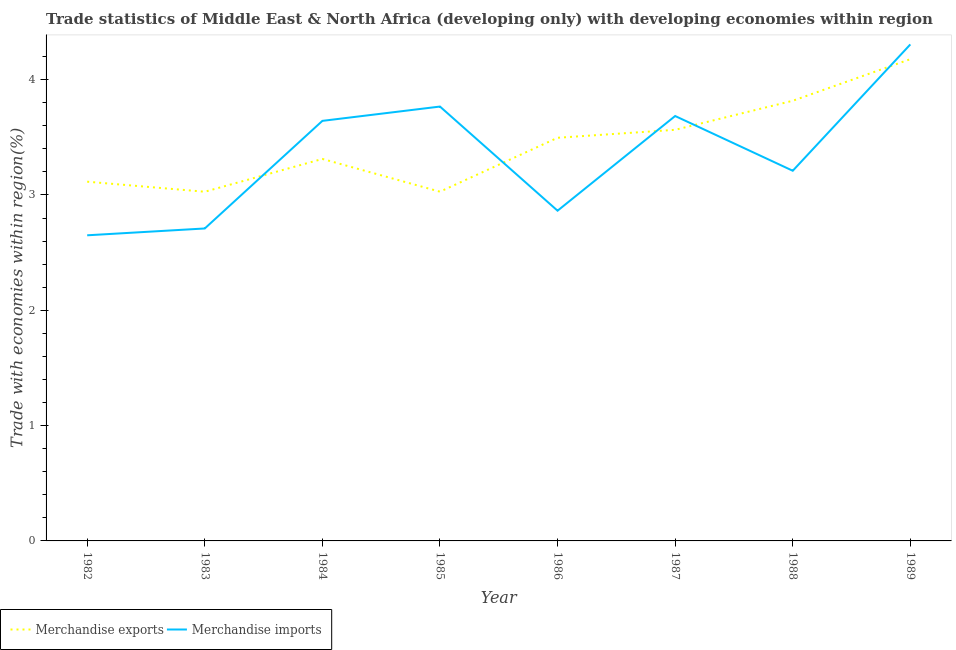How many different coloured lines are there?
Ensure brevity in your answer.  2. Does the line corresponding to merchandise exports intersect with the line corresponding to merchandise imports?
Provide a short and direct response. Yes. Is the number of lines equal to the number of legend labels?
Make the answer very short. Yes. What is the merchandise imports in 1987?
Your response must be concise. 3.68. Across all years, what is the maximum merchandise imports?
Ensure brevity in your answer.  4.31. Across all years, what is the minimum merchandise imports?
Provide a short and direct response. 2.65. In which year was the merchandise exports maximum?
Your response must be concise. 1989. What is the total merchandise imports in the graph?
Give a very brief answer. 26.83. What is the difference between the merchandise imports in 1982 and that in 1988?
Keep it short and to the point. -0.56. What is the difference between the merchandise exports in 1985 and the merchandise imports in 1984?
Ensure brevity in your answer.  -0.61. What is the average merchandise imports per year?
Your answer should be very brief. 3.35. In the year 1988, what is the difference between the merchandise exports and merchandise imports?
Make the answer very short. 0.61. What is the ratio of the merchandise imports in 1984 to that in 1987?
Keep it short and to the point. 0.99. What is the difference between the highest and the second highest merchandise imports?
Offer a terse response. 0.54. What is the difference between the highest and the lowest merchandise imports?
Your answer should be compact. 1.66. In how many years, is the merchandise imports greater than the average merchandise imports taken over all years?
Offer a very short reply. 4. Is the sum of the merchandise exports in 1983 and 1989 greater than the maximum merchandise imports across all years?
Provide a short and direct response. Yes. Is the merchandise exports strictly greater than the merchandise imports over the years?
Provide a succinct answer. No. How many lines are there?
Provide a short and direct response. 2. Are the values on the major ticks of Y-axis written in scientific E-notation?
Give a very brief answer. No. Does the graph contain any zero values?
Your response must be concise. No. Where does the legend appear in the graph?
Provide a succinct answer. Bottom left. How many legend labels are there?
Provide a short and direct response. 2. What is the title of the graph?
Ensure brevity in your answer.  Trade statistics of Middle East & North Africa (developing only) with developing economies within region. Does "Primary" appear as one of the legend labels in the graph?
Ensure brevity in your answer.  No. What is the label or title of the X-axis?
Your answer should be compact. Year. What is the label or title of the Y-axis?
Offer a terse response. Trade with economies within region(%). What is the Trade with economies within region(%) of Merchandise exports in 1982?
Give a very brief answer. 3.12. What is the Trade with economies within region(%) of Merchandise imports in 1982?
Your answer should be compact. 2.65. What is the Trade with economies within region(%) in Merchandise exports in 1983?
Your answer should be very brief. 3.03. What is the Trade with economies within region(%) of Merchandise imports in 1983?
Provide a short and direct response. 2.71. What is the Trade with economies within region(%) in Merchandise exports in 1984?
Ensure brevity in your answer.  3.31. What is the Trade with economies within region(%) in Merchandise imports in 1984?
Provide a short and direct response. 3.64. What is the Trade with economies within region(%) in Merchandise exports in 1985?
Provide a short and direct response. 3.03. What is the Trade with economies within region(%) in Merchandise imports in 1985?
Offer a terse response. 3.77. What is the Trade with economies within region(%) of Merchandise exports in 1986?
Offer a very short reply. 3.5. What is the Trade with economies within region(%) of Merchandise imports in 1986?
Offer a terse response. 2.86. What is the Trade with economies within region(%) in Merchandise exports in 1987?
Offer a very short reply. 3.57. What is the Trade with economies within region(%) of Merchandise imports in 1987?
Offer a very short reply. 3.68. What is the Trade with economies within region(%) in Merchandise exports in 1988?
Offer a terse response. 3.82. What is the Trade with economies within region(%) of Merchandise imports in 1988?
Your answer should be compact. 3.21. What is the Trade with economies within region(%) of Merchandise exports in 1989?
Offer a very short reply. 4.18. What is the Trade with economies within region(%) of Merchandise imports in 1989?
Provide a short and direct response. 4.31. Across all years, what is the maximum Trade with economies within region(%) of Merchandise exports?
Give a very brief answer. 4.18. Across all years, what is the maximum Trade with economies within region(%) in Merchandise imports?
Keep it short and to the point. 4.31. Across all years, what is the minimum Trade with economies within region(%) in Merchandise exports?
Provide a succinct answer. 3.03. Across all years, what is the minimum Trade with economies within region(%) of Merchandise imports?
Ensure brevity in your answer.  2.65. What is the total Trade with economies within region(%) in Merchandise exports in the graph?
Your answer should be very brief. 27.54. What is the total Trade with economies within region(%) of Merchandise imports in the graph?
Ensure brevity in your answer.  26.83. What is the difference between the Trade with economies within region(%) in Merchandise exports in 1982 and that in 1983?
Ensure brevity in your answer.  0.09. What is the difference between the Trade with economies within region(%) of Merchandise imports in 1982 and that in 1983?
Keep it short and to the point. -0.06. What is the difference between the Trade with economies within region(%) in Merchandise exports in 1982 and that in 1984?
Your answer should be compact. -0.2. What is the difference between the Trade with economies within region(%) in Merchandise imports in 1982 and that in 1984?
Your answer should be compact. -0.99. What is the difference between the Trade with economies within region(%) in Merchandise exports in 1982 and that in 1985?
Your response must be concise. 0.09. What is the difference between the Trade with economies within region(%) in Merchandise imports in 1982 and that in 1985?
Keep it short and to the point. -1.12. What is the difference between the Trade with economies within region(%) of Merchandise exports in 1982 and that in 1986?
Give a very brief answer. -0.38. What is the difference between the Trade with economies within region(%) in Merchandise imports in 1982 and that in 1986?
Make the answer very short. -0.21. What is the difference between the Trade with economies within region(%) in Merchandise exports in 1982 and that in 1987?
Your answer should be very brief. -0.45. What is the difference between the Trade with economies within region(%) in Merchandise imports in 1982 and that in 1987?
Keep it short and to the point. -1.03. What is the difference between the Trade with economies within region(%) in Merchandise exports in 1982 and that in 1988?
Keep it short and to the point. -0.7. What is the difference between the Trade with economies within region(%) of Merchandise imports in 1982 and that in 1988?
Give a very brief answer. -0.56. What is the difference between the Trade with economies within region(%) in Merchandise exports in 1982 and that in 1989?
Provide a succinct answer. -1.06. What is the difference between the Trade with economies within region(%) in Merchandise imports in 1982 and that in 1989?
Your answer should be compact. -1.66. What is the difference between the Trade with economies within region(%) in Merchandise exports in 1983 and that in 1984?
Offer a terse response. -0.28. What is the difference between the Trade with economies within region(%) of Merchandise imports in 1983 and that in 1984?
Give a very brief answer. -0.93. What is the difference between the Trade with economies within region(%) of Merchandise exports in 1983 and that in 1985?
Provide a short and direct response. -0. What is the difference between the Trade with economies within region(%) of Merchandise imports in 1983 and that in 1985?
Give a very brief answer. -1.06. What is the difference between the Trade with economies within region(%) of Merchandise exports in 1983 and that in 1986?
Provide a succinct answer. -0.47. What is the difference between the Trade with economies within region(%) in Merchandise imports in 1983 and that in 1986?
Provide a short and direct response. -0.15. What is the difference between the Trade with economies within region(%) of Merchandise exports in 1983 and that in 1987?
Provide a short and direct response. -0.54. What is the difference between the Trade with economies within region(%) of Merchandise imports in 1983 and that in 1987?
Your answer should be very brief. -0.98. What is the difference between the Trade with economies within region(%) in Merchandise exports in 1983 and that in 1988?
Keep it short and to the point. -0.79. What is the difference between the Trade with economies within region(%) in Merchandise imports in 1983 and that in 1988?
Your response must be concise. -0.5. What is the difference between the Trade with economies within region(%) of Merchandise exports in 1983 and that in 1989?
Give a very brief answer. -1.15. What is the difference between the Trade with economies within region(%) in Merchandise imports in 1983 and that in 1989?
Provide a succinct answer. -1.6. What is the difference between the Trade with economies within region(%) of Merchandise exports in 1984 and that in 1985?
Give a very brief answer. 0.28. What is the difference between the Trade with economies within region(%) in Merchandise imports in 1984 and that in 1985?
Ensure brevity in your answer.  -0.12. What is the difference between the Trade with economies within region(%) in Merchandise exports in 1984 and that in 1986?
Provide a succinct answer. -0.18. What is the difference between the Trade with economies within region(%) of Merchandise imports in 1984 and that in 1986?
Keep it short and to the point. 0.78. What is the difference between the Trade with economies within region(%) of Merchandise exports in 1984 and that in 1987?
Make the answer very short. -0.25. What is the difference between the Trade with economies within region(%) in Merchandise imports in 1984 and that in 1987?
Your answer should be compact. -0.04. What is the difference between the Trade with economies within region(%) in Merchandise exports in 1984 and that in 1988?
Provide a succinct answer. -0.5. What is the difference between the Trade with economies within region(%) in Merchandise imports in 1984 and that in 1988?
Your answer should be compact. 0.43. What is the difference between the Trade with economies within region(%) in Merchandise exports in 1984 and that in 1989?
Offer a terse response. -0.87. What is the difference between the Trade with economies within region(%) of Merchandise imports in 1984 and that in 1989?
Offer a terse response. -0.66. What is the difference between the Trade with economies within region(%) of Merchandise exports in 1985 and that in 1986?
Offer a terse response. -0.47. What is the difference between the Trade with economies within region(%) in Merchandise imports in 1985 and that in 1986?
Your answer should be compact. 0.9. What is the difference between the Trade with economies within region(%) of Merchandise exports in 1985 and that in 1987?
Your response must be concise. -0.54. What is the difference between the Trade with economies within region(%) in Merchandise imports in 1985 and that in 1987?
Offer a very short reply. 0.08. What is the difference between the Trade with economies within region(%) of Merchandise exports in 1985 and that in 1988?
Make the answer very short. -0.79. What is the difference between the Trade with economies within region(%) in Merchandise imports in 1985 and that in 1988?
Your answer should be compact. 0.56. What is the difference between the Trade with economies within region(%) in Merchandise exports in 1985 and that in 1989?
Your answer should be very brief. -1.15. What is the difference between the Trade with economies within region(%) of Merchandise imports in 1985 and that in 1989?
Offer a terse response. -0.54. What is the difference between the Trade with economies within region(%) in Merchandise exports in 1986 and that in 1987?
Make the answer very short. -0.07. What is the difference between the Trade with economies within region(%) of Merchandise imports in 1986 and that in 1987?
Your answer should be very brief. -0.82. What is the difference between the Trade with economies within region(%) of Merchandise exports in 1986 and that in 1988?
Offer a terse response. -0.32. What is the difference between the Trade with economies within region(%) in Merchandise imports in 1986 and that in 1988?
Your answer should be very brief. -0.35. What is the difference between the Trade with economies within region(%) in Merchandise exports in 1986 and that in 1989?
Your answer should be compact. -0.68. What is the difference between the Trade with economies within region(%) of Merchandise imports in 1986 and that in 1989?
Provide a short and direct response. -1.44. What is the difference between the Trade with economies within region(%) in Merchandise exports in 1987 and that in 1988?
Provide a succinct answer. -0.25. What is the difference between the Trade with economies within region(%) of Merchandise imports in 1987 and that in 1988?
Give a very brief answer. 0.47. What is the difference between the Trade with economies within region(%) of Merchandise exports in 1987 and that in 1989?
Offer a terse response. -0.61. What is the difference between the Trade with economies within region(%) in Merchandise imports in 1987 and that in 1989?
Offer a terse response. -0.62. What is the difference between the Trade with economies within region(%) in Merchandise exports in 1988 and that in 1989?
Provide a short and direct response. -0.36. What is the difference between the Trade with economies within region(%) of Merchandise imports in 1988 and that in 1989?
Provide a short and direct response. -1.1. What is the difference between the Trade with economies within region(%) in Merchandise exports in 1982 and the Trade with economies within region(%) in Merchandise imports in 1983?
Ensure brevity in your answer.  0.41. What is the difference between the Trade with economies within region(%) in Merchandise exports in 1982 and the Trade with economies within region(%) in Merchandise imports in 1984?
Give a very brief answer. -0.53. What is the difference between the Trade with economies within region(%) of Merchandise exports in 1982 and the Trade with economies within region(%) of Merchandise imports in 1985?
Keep it short and to the point. -0.65. What is the difference between the Trade with economies within region(%) in Merchandise exports in 1982 and the Trade with economies within region(%) in Merchandise imports in 1986?
Provide a short and direct response. 0.25. What is the difference between the Trade with economies within region(%) in Merchandise exports in 1982 and the Trade with economies within region(%) in Merchandise imports in 1987?
Provide a succinct answer. -0.57. What is the difference between the Trade with economies within region(%) of Merchandise exports in 1982 and the Trade with economies within region(%) of Merchandise imports in 1988?
Make the answer very short. -0.09. What is the difference between the Trade with economies within region(%) in Merchandise exports in 1982 and the Trade with economies within region(%) in Merchandise imports in 1989?
Provide a short and direct response. -1.19. What is the difference between the Trade with economies within region(%) in Merchandise exports in 1983 and the Trade with economies within region(%) in Merchandise imports in 1984?
Give a very brief answer. -0.61. What is the difference between the Trade with economies within region(%) of Merchandise exports in 1983 and the Trade with economies within region(%) of Merchandise imports in 1985?
Offer a very short reply. -0.74. What is the difference between the Trade with economies within region(%) of Merchandise exports in 1983 and the Trade with economies within region(%) of Merchandise imports in 1986?
Your response must be concise. 0.16. What is the difference between the Trade with economies within region(%) in Merchandise exports in 1983 and the Trade with economies within region(%) in Merchandise imports in 1987?
Provide a succinct answer. -0.66. What is the difference between the Trade with economies within region(%) in Merchandise exports in 1983 and the Trade with economies within region(%) in Merchandise imports in 1988?
Your answer should be compact. -0.18. What is the difference between the Trade with economies within region(%) in Merchandise exports in 1983 and the Trade with economies within region(%) in Merchandise imports in 1989?
Offer a very short reply. -1.28. What is the difference between the Trade with economies within region(%) in Merchandise exports in 1984 and the Trade with economies within region(%) in Merchandise imports in 1985?
Provide a succinct answer. -0.45. What is the difference between the Trade with economies within region(%) in Merchandise exports in 1984 and the Trade with economies within region(%) in Merchandise imports in 1986?
Provide a short and direct response. 0.45. What is the difference between the Trade with economies within region(%) of Merchandise exports in 1984 and the Trade with economies within region(%) of Merchandise imports in 1987?
Offer a terse response. -0.37. What is the difference between the Trade with economies within region(%) in Merchandise exports in 1984 and the Trade with economies within region(%) in Merchandise imports in 1988?
Offer a terse response. 0.1. What is the difference between the Trade with economies within region(%) of Merchandise exports in 1984 and the Trade with economies within region(%) of Merchandise imports in 1989?
Your answer should be very brief. -0.99. What is the difference between the Trade with economies within region(%) in Merchandise exports in 1985 and the Trade with economies within region(%) in Merchandise imports in 1986?
Keep it short and to the point. 0.16. What is the difference between the Trade with economies within region(%) of Merchandise exports in 1985 and the Trade with economies within region(%) of Merchandise imports in 1987?
Make the answer very short. -0.66. What is the difference between the Trade with economies within region(%) of Merchandise exports in 1985 and the Trade with economies within region(%) of Merchandise imports in 1988?
Provide a succinct answer. -0.18. What is the difference between the Trade with economies within region(%) of Merchandise exports in 1985 and the Trade with economies within region(%) of Merchandise imports in 1989?
Give a very brief answer. -1.28. What is the difference between the Trade with economies within region(%) of Merchandise exports in 1986 and the Trade with economies within region(%) of Merchandise imports in 1987?
Ensure brevity in your answer.  -0.19. What is the difference between the Trade with economies within region(%) in Merchandise exports in 1986 and the Trade with economies within region(%) in Merchandise imports in 1988?
Offer a very short reply. 0.29. What is the difference between the Trade with economies within region(%) of Merchandise exports in 1986 and the Trade with economies within region(%) of Merchandise imports in 1989?
Offer a very short reply. -0.81. What is the difference between the Trade with economies within region(%) of Merchandise exports in 1987 and the Trade with economies within region(%) of Merchandise imports in 1988?
Offer a terse response. 0.35. What is the difference between the Trade with economies within region(%) of Merchandise exports in 1987 and the Trade with economies within region(%) of Merchandise imports in 1989?
Your answer should be compact. -0.74. What is the difference between the Trade with economies within region(%) in Merchandise exports in 1988 and the Trade with economies within region(%) in Merchandise imports in 1989?
Ensure brevity in your answer.  -0.49. What is the average Trade with economies within region(%) in Merchandise exports per year?
Ensure brevity in your answer.  3.44. What is the average Trade with economies within region(%) of Merchandise imports per year?
Provide a short and direct response. 3.35. In the year 1982, what is the difference between the Trade with economies within region(%) of Merchandise exports and Trade with economies within region(%) of Merchandise imports?
Offer a very short reply. 0.46. In the year 1983, what is the difference between the Trade with economies within region(%) in Merchandise exports and Trade with economies within region(%) in Merchandise imports?
Give a very brief answer. 0.32. In the year 1984, what is the difference between the Trade with economies within region(%) in Merchandise exports and Trade with economies within region(%) in Merchandise imports?
Your response must be concise. -0.33. In the year 1985, what is the difference between the Trade with economies within region(%) of Merchandise exports and Trade with economies within region(%) of Merchandise imports?
Provide a short and direct response. -0.74. In the year 1986, what is the difference between the Trade with economies within region(%) of Merchandise exports and Trade with economies within region(%) of Merchandise imports?
Your answer should be compact. 0.63. In the year 1987, what is the difference between the Trade with economies within region(%) in Merchandise exports and Trade with economies within region(%) in Merchandise imports?
Your response must be concise. -0.12. In the year 1988, what is the difference between the Trade with economies within region(%) of Merchandise exports and Trade with economies within region(%) of Merchandise imports?
Provide a succinct answer. 0.61. In the year 1989, what is the difference between the Trade with economies within region(%) of Merchandise exports and Trade with economies within region(%) of Merchandise imports?
Your response must be concise. -0.13. What is the ratio of the Trade with economies within region(%) in Merchandise exports in 1982 to that in 1983?
Offer a terse response. 1.03. What is the ratio of the Trade with economies within region(%) of Merchandise imports in 1982 to that in 1983?
Ensure brevity in your answer.  0.98. What is the ratio of the Trade with economies within region(%) of Merchandise exports in 1982 to that in 1984?
Give a very brief answer. 0.94. What is the ratio of the Trade with economies within region(%) of Merchandise imports in 1982 to that in 1984?
Your answer should be very brief. 0.73. What is the ratio of the Trade with economies within region(%) of Merchandise exports in 1982 to that in 1985?
Provide a succinct answer. 1.03. What is the ratio of the Trade with economies within region(%) in Merchandise imports in 1982 to that in 1985?
Offer a terse response. 0.7. What is the ratio of the Trade with economies within region(%) of Merchandise exports in 1982 to that in 1986?
Your response must be concise. 0.89. What is the ratio of the Trade with economies within region(%) in Merchandise imports in 1982 to that in 1986?
Provide a short and direct response. 0.93. What is the ratio of the Trade with economies within region(%) in Merchandise exports in 1982 to that in 1987?
Provide a short and direct response. 0.87. What is the ratio of the Trade with economies within region(%) of Merchandise imports in 1982 to that in 1987?
Give a very brief answer. 0.72. What is the ratio of the Trade with economies within region(%) in Merchandise exports in 1982 to that in 1988?
Offer a terse response. 0.82. What is the ratio of the Trade with economies within region(%) of Merchandise imports in 1982 to that in 1988?
Provide a succinct answer. 0.83. What is the ratio of the Trade with economies within region(%) in Merchandise exports in 1982 to that in 1989?
Keep it short and to the point. 0.75. What is the ratio of the Trade with economies within region(%) in Merchandise imports in 1982 to that in 1989?
Ensure brevity in your answer.  0.62. What is the ratio of the Trade with economies within region(%) in Merchandise exports in 1983 to that in 1984?
Ensure brevity in your answer.  0.91. What is the ratio of the Trade with economies within region(%) in Merchandise imports in 1983 to that in 1984?
Keep it short and to the point. 0.74. What is the ratio of the Trade with economies within region(%) of Merchandise exports in 1983 to that in 1985?
Provide a succinct answer. 1. What is the ratio of the Trade with economies within region(%) in Merchandise imports in 1983 to that in 1985?
Your answer should be very brief. 0.72. What is the ratio of the Trade with economies within region(%) of Merchandise exports in 1983 to that in 1986?
Your response must be concise. 0.87. What is the ratio of the Trade with economies within region(%) of Merchandise imports in 1983 to that in 1986?
Offer a terse response. 0.95. What is the ratio of the Trade with economies within region(%) in Merchandise exports in 1983 to that in 1987?
Keep it short and to the point. 0.85. What is the ratio of the Trade with economies within region(%) of Merchandise imports in 1983 to that in 1987?
Offer a terse response. 0.74. What is the ratio of the Trade with economies within region(%) in Merchandise exports in 1983 to that in 1988?
Ensure brevity in your answer.  0.79. What is the ratio of the Trade with economies within region(%) of Merchandise imports in 1983 to that in 1988?
Keep it short and to the point. 0.84. What is the ratio of the Trade with economies within region(%) in Merchandise exports in 1983 to that in 1989?
Give a very brief answer. 0.72. What is the ratio of the Trade with economies within region(%) in Merchandise imports in 1983 to that in 1989?
Make the answer very short. 0.63. What is the ratio of the Trade with economies within region(%) of Merchandise exports in 1984 to that in 1985?
Keep it short and to the point. 1.09. What is the ratio of the Trade with economies within region(%) in Merchandise imports in 1984 to that in 1985?
Your response must be concise. 0.97. What is the ratio of the Trade with economies within region(%) of Merchandise exports in 1984 to that in 1986?
Keep it short and to the point. 0.95. What is the ratio of the Trade with economies within region(%) in Merchandise imports in 1984 to that in 1986?
Offer a very short reply. 1.27. What is the ratio of the Trade with economies within region(%) of Merchandise exports in 1984 to that in 1987?
Make the answer very short. 0.93. What is the ratio of the Trade with economies within region(%) in Merchandise exports in 1984 to that in 1988?
Make the answer very short. 0.87. What is the ratio of the Trade with economies within region(%) of Merchandise imports in 1984 to that in 1988?
Your answer should be very brief. 1.13. What is the ratio of the Trade with economies within region(%) in Merchandise exports in 1984 to that in 1989?
Give a very brief answer. 0.79. What is the ratio of the Trade with economies within region(%) of Merchandise imports in 1984 to that in 1989?
Make the answer very short. 0.85. What is the ratio of the Trade with economies within region(%) of Merchandise exports in 1985 to that in 1986?
Your answer should be very brief. 0.87. What is the ratio of the Trade with economies within region(%) of Merchandise imports in 1985 to that in 1986?
Ensure brevity in your answer.  1.32. What is the ratio of the Trade with economies within region(%) in Merchandise exports in 1985 to that in 1987?
Offer a terse response. 0.85. What is the ratio of the Trade with economies within region(%) of Merchandise imports in 1985 to that in 1987?
Your answer should be very brief. 1.02. What is the ratio of the Trade with economies within region(%) in Merchandise exports in 1985 to that in 1988?
Your answer should be compact. 0.79. What is the ratio of the Trade with economies within region(%) of Merchandise imports in 1985 to that in 1988?
Give a very brief answer. 1.17. What is the ratio of the Trade with economies within region(%) of Merchandise exports in 1985 to that in 1989?
Provide a succinct answer. 0.72. What is the ratio of the Trade with economies within region(%) in Merchandise imports in 1985 to that in 1989?
Offer a very short reply. 0.87. What is the ratio of the Trade with economies within region(%) in Merchandise exports in 1986 to that in 1987?
Provide a succinct answer. 0.98. What is the ratio of the Trade with economies within region(%) in Merchandise imports in 1986 to that in 1987?
Make the answer very short. 0.78. What is the ratio of the Trade with economies within region(%) of Merchandise exports in 1986 to that in 1988?
Your response must be concise. 0.92. What is the ratio of the Trade with economies within region(%) in Merchandise imports in 1986 to that in 1988?
Give a very brief answer. 0.89. What is the ratio of the Trade with economies within region(%) in Merchandise exports in 1986 to that in 1989?
Offer a very short reply. 0.84. What is the ratio of the Trade with economies within region(%) of Merchandise imports in 1986 to that in 1989?
Your answer should be very brief. 0.67. What is the ratio of the Trade with economies within region(%) in Merchandise exports in 1987 to that in 1988?
Give a very brief answer. 0.93. What is the ratio of the Trade with economies within region(%) of Merchandise imports in 1987 to that in 1988?
Provide a succinct answer. 1.15. What is the ratio of the Trade with economies within region(%) in Merchandise exports in 1987 to that in 1989?
Provide a short and direct response. 0.85. What is the ratio of the Trade with economies within region(%) in Merchandise imports in 1987 to that in 1989?
Provide a succinct answer. 0.86. What is the ratio of the Trade with economies within region(%) in Merchandise exports in 1988 to that in 1989?
Ensure brevity in your answer.  0.91. What is the ratio of the Trade with economies within region(%) of Merchandise imports in 1988 to that in 1989?
Offer a very short reply. 0.75. What is the difference between the highest and the second highest Trade with economies within region(%) in Merchandise exports?
Ensure brevity in your answer.  0.36. What is the difference between the highest and the second highest Trade with economies within region(%) in Merchandise imports?
Provide a succinct answer. 0.54. What is the difference between the highest and the lowest Trade with economies within region(%) of Merchandise exports?
Ensure brevity in your answer.  1.15. What is the difference between the highest and the lowest Trade with economies within region(%) in Merchandise imports?
Give a very brief answer. 1.66. 